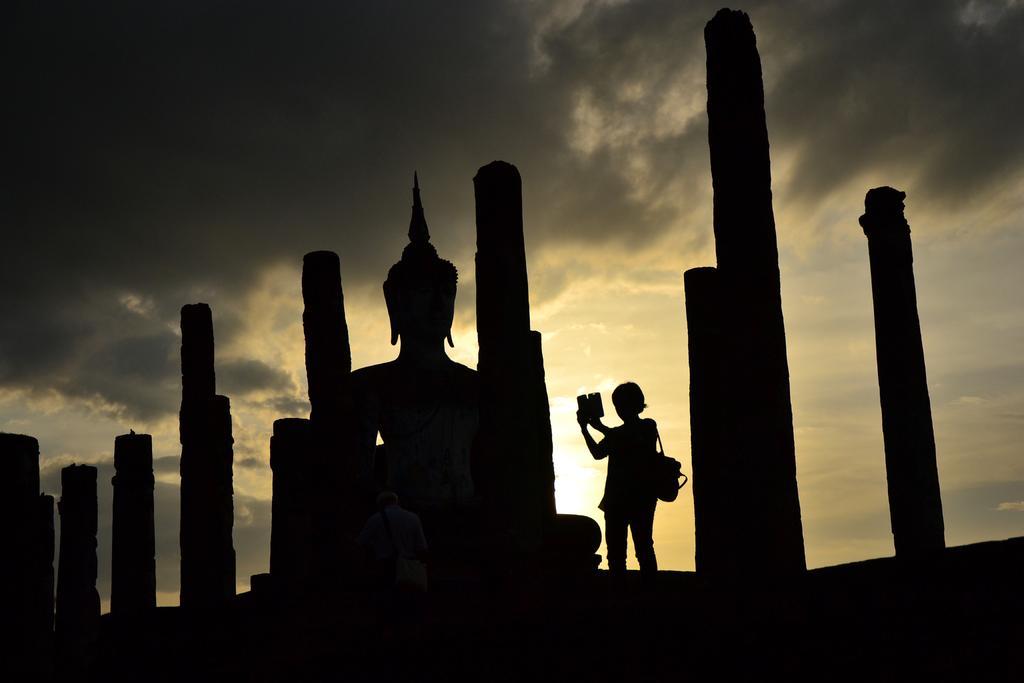Can you describe this image briefly? In this image we can see some pillars, there is a sculpture, and a person wearing a backpack, and holding a cell phone, also we can see the sun, clouds, and the sky. 